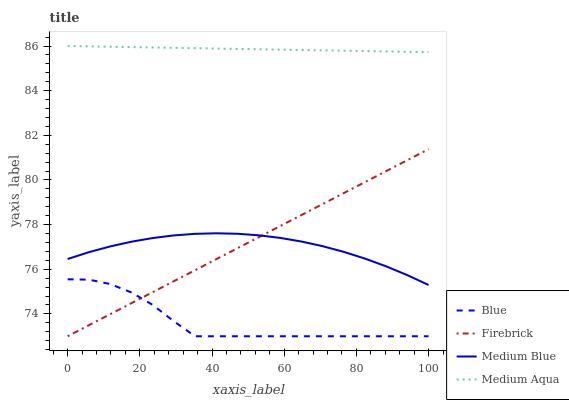Does Blue have the minimum area under the curve?
Answer yes or no. Yes. Does Medium Aqua have the maximum area under the curve?
Answer yes or no. Yes. Does Firebrick have the minimum area under the curve?
Answer yes or no. No. Does Firebrick have the maximum area under the curve?
Answer yes or no. No. Is Firebrick the smoothest?
Answer yes or no. Yes. Is Blue the roughest?
Answer yes or no. Yes. Is Medium Aqua the smoothest?
Answer yes or no. No. Is Medium Aqua the roughest?
Answer yes or no. No. Does Medium Aqua have the lowest value?
Answer yes or no. No. Does Medium Aqua have the highest value?
Answer yes or no. Yes. Does Firebrick have the highest value?
Answer yes or no. No. Is Firebrick less than Medium Aqua?
Answer yes or no. Yes. Is Medium Aqua greater than Medium Blue?
Answer yes or no. Yes. Does Blue intersect Firebrick?
Answer yes or no. Yes. Is Blue less than Firebrick?
Answer yes or no. No. Is Blue greater than Firebrick?
Answer yes or no. No. Does Firebrick intersect Medium Aqua?
Answer yes or no. No. 